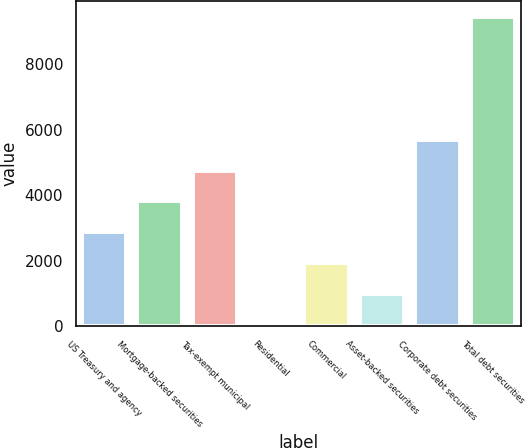Convert chart to OTSL. <chart><loc_0><loc_0><loc_500><loc_500><bar_chart><fcel>US Treasury and agency<fcel>Mortgage-backed securities<fcel>Tax-exempt municipal<fcel>Residential<fcel>Commercial<fcel>Asset-backed securities<fcel>Corporate debt securities<fcel>Total debt securities<nl><fcel>2866.7<fcel>3807.6<fcel>4748.5<fcel>44<fcel>1925.8<fcel>984.9<fcel>5689.4<fcel>9453<nl></chart> 